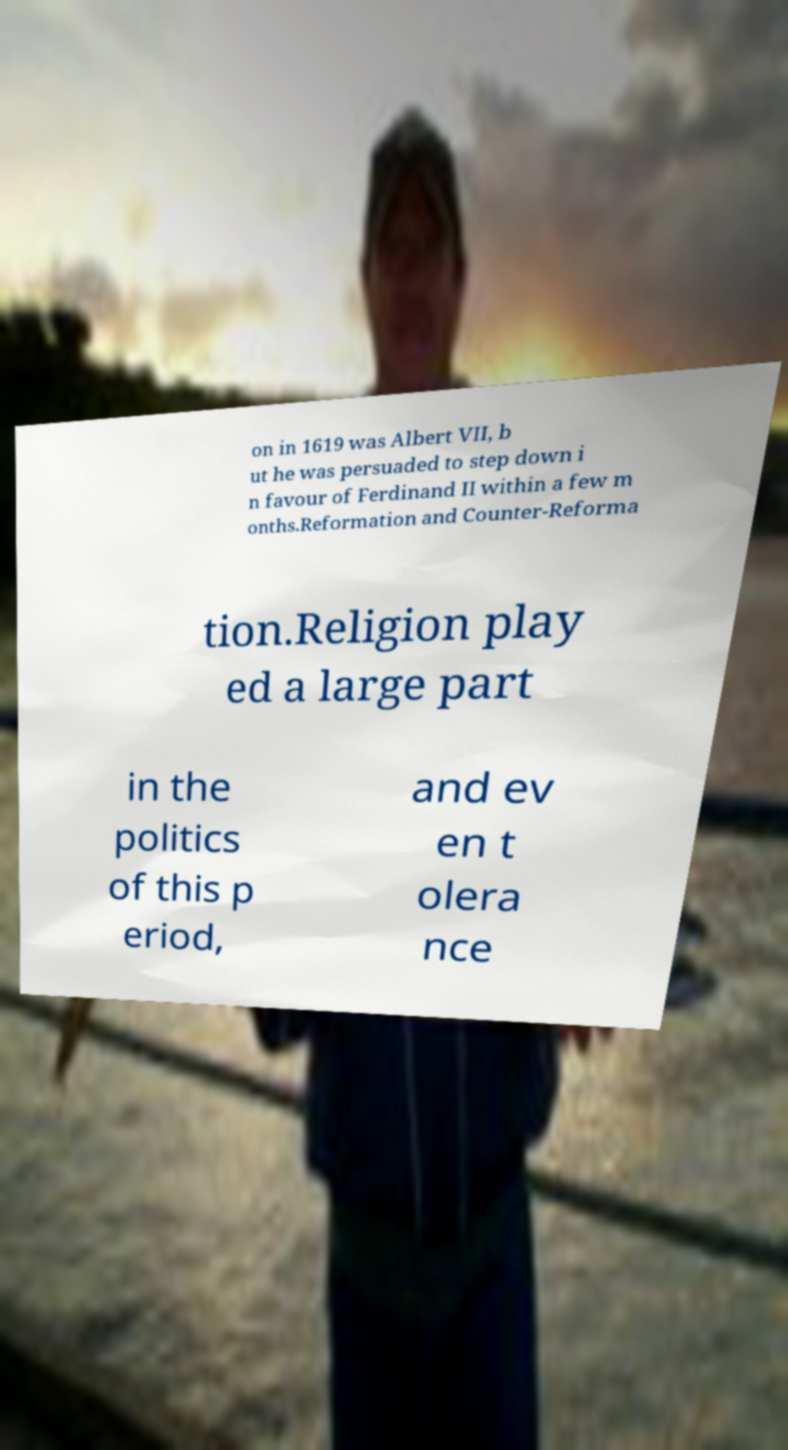I need the written content from this picture converted into text. Can you do that? on in 1619 was Albert VII, b ut he was persuaded to step down i n favour of Ferdinand II within a few m onths.Reformation and Counter-Reforma tion.Religion play ed a large part in the politics of this p eriod, and ev en t olera nce 